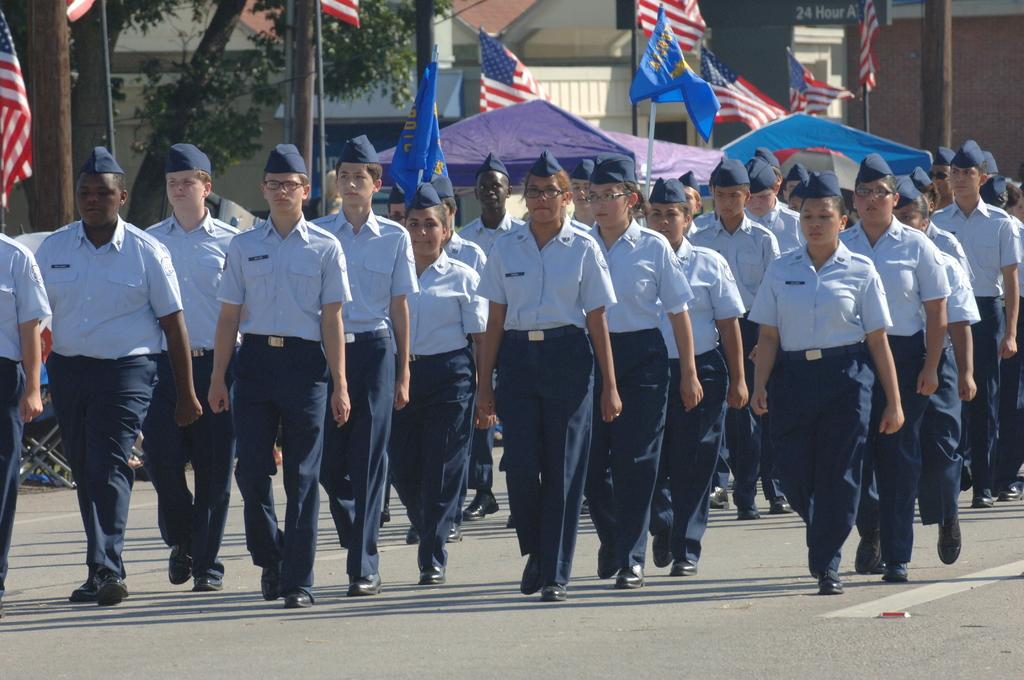Please provide a concise description of this image. In this image there are group of people standing , and in the background there are flags with poles, tent, building, trees. 